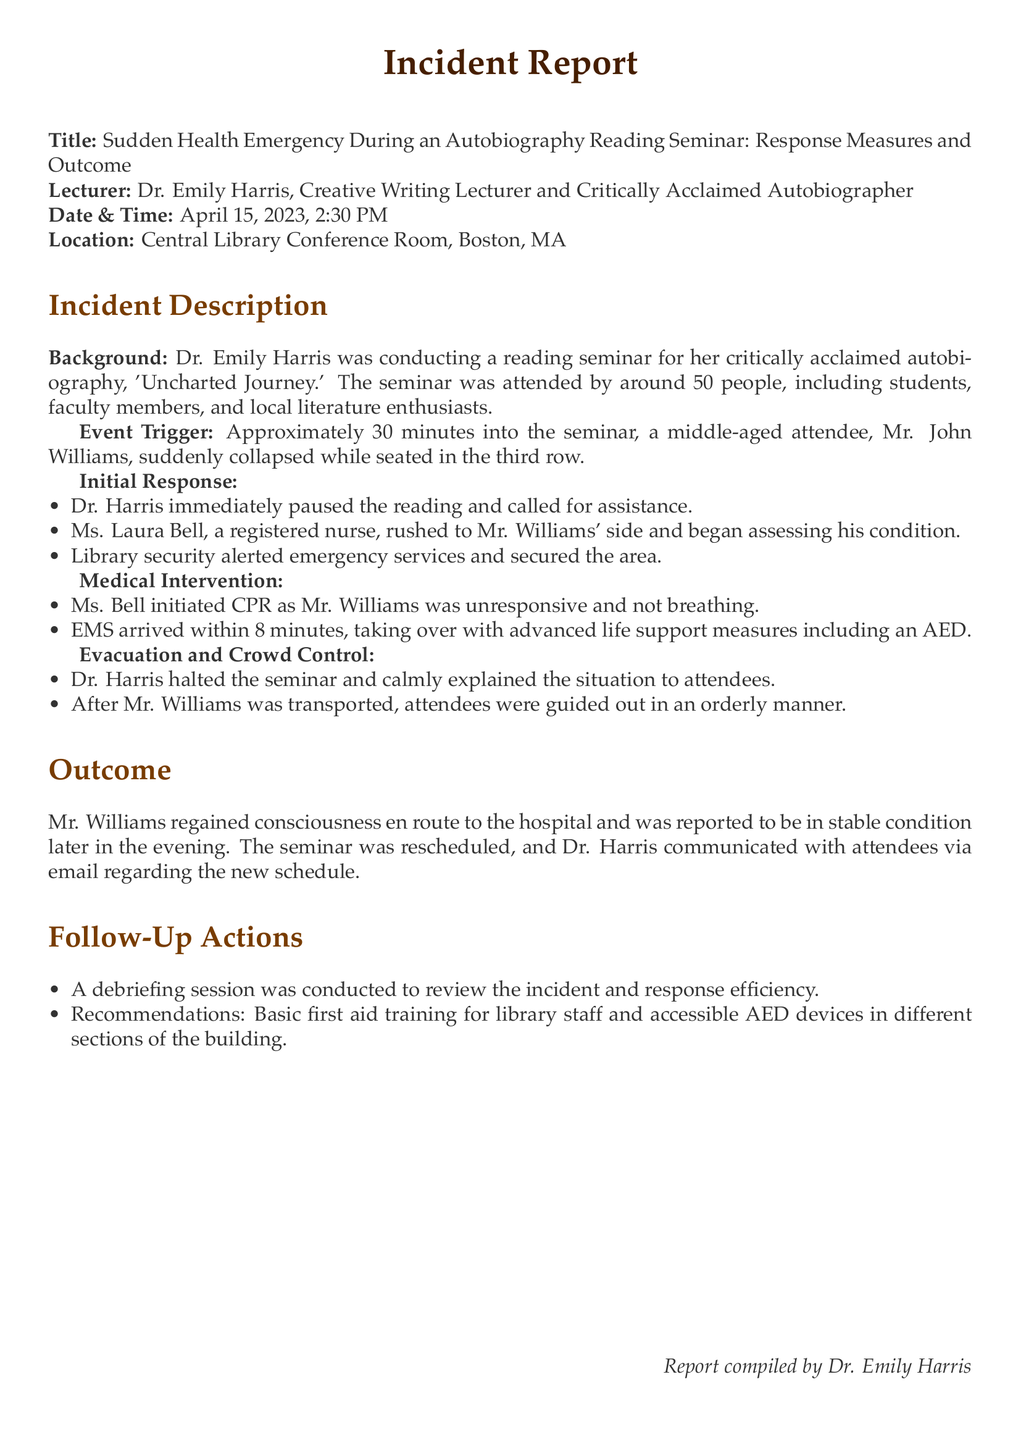What was the title of the autobiography? The title of the autobiography discussed in the seminar is mentioned as 'Uncharted Journey.'
Answer: 'Uncharted Journey' Who collapsed during the seminar? The document states that Mr. John Williams was the individual who collapsed during the seminar.
Answer: Mr. John Williams What is the date of the incident? The incident occurred on April 15, 2023, as specified in the report.
Answer: April 15, 2023 How many people attended the seminar? The report mentions that approximately 50 people attended the seminar.
Answer: approximately 50 What type of medical intervention was initiated by Ms. Bell? Ms. Bell started performing CPR, which is a specific type of medical intervention mentioned in the report.
Answer: CPR How long did it take for emergency services to arrive? The report indicates that EMS arrived within 8 minutes after the incident occurred.
Answer: 8 minutes What follow-up action was recommended for library staff? The document states a recommendation for basic first aid training for library staff as a follow-up action.
Answer: basic first aid training What was the outcome for Mr. Williams after the incident? The report specifies that Mr. Williams regained consciousness en route to the hospital and was reported to be in stable condition.
Answer: stable condition What kind of report is this? This document is classified as an incident report, which is clearly stated at the beginning.
Answer: incident report 